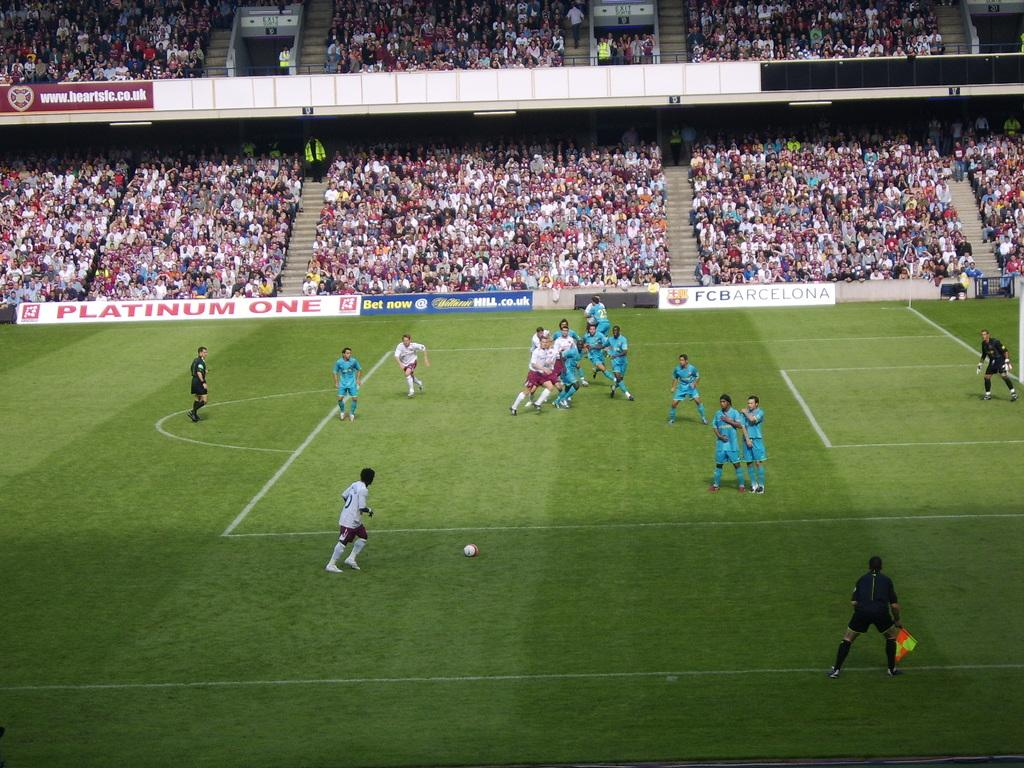What is happening in the image? There is a crowd in the image, and some persons are playing football. What are the persons wearing? The persons are wearing clothes. Can you describe the activity taking place in the image? The persons are playing football. Can you hear the whistle during the discussion in the image? There is no whistle or discussion present in the image; it shows a crowd of people playing football. 